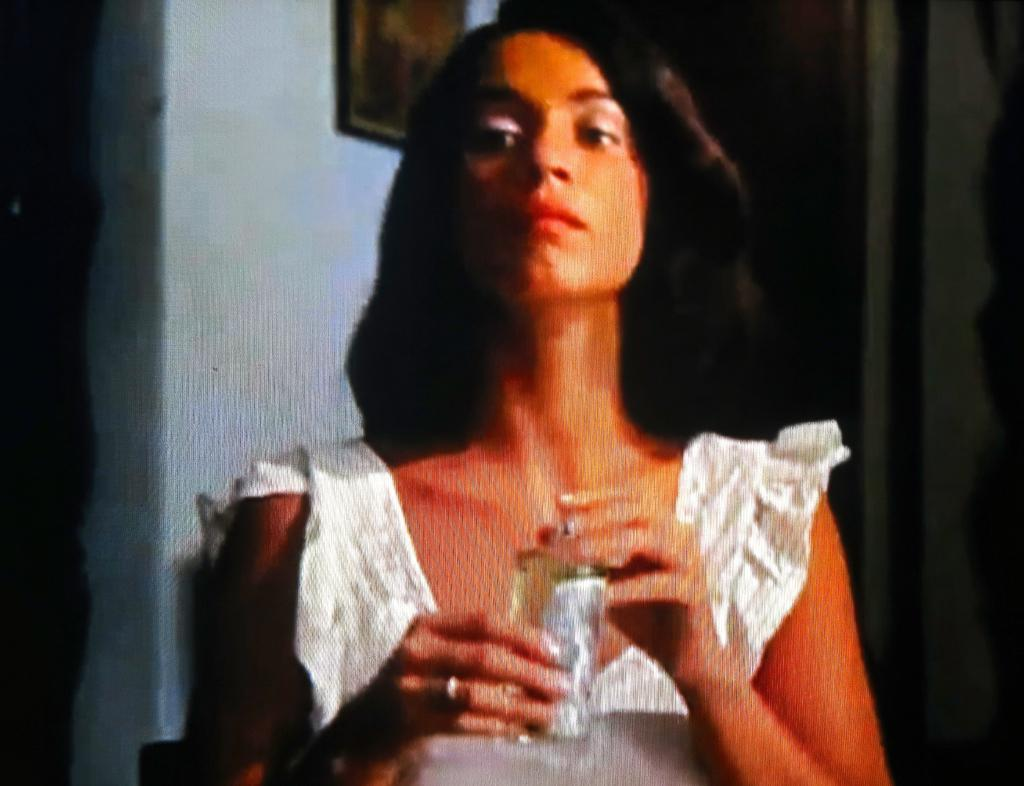Who is present in the image? There is a woman in the image. What is the woman holding in the image? The woman is holding a bottle. What can be seen on the wall in the image? There is a frame on the wall in the image. What type of patch is the woman sewing onto the rod in the image? There is no patch or rod present in the image; the woman is holding a bottle and there is a frame on the wall. 